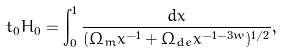<formula> <loc_0><loc_0><loc_500><loc_500>t _ { 0 } H _ { 0 } = \int _ { 0 } ^ { 1 } \frac { d x } { ( \Omega _ { m } x ^ { - 1 } + \Omega _ { d e } x ^ { - 1 - 3 w } ) ^ { 1 / 2 } } ,</formula> 